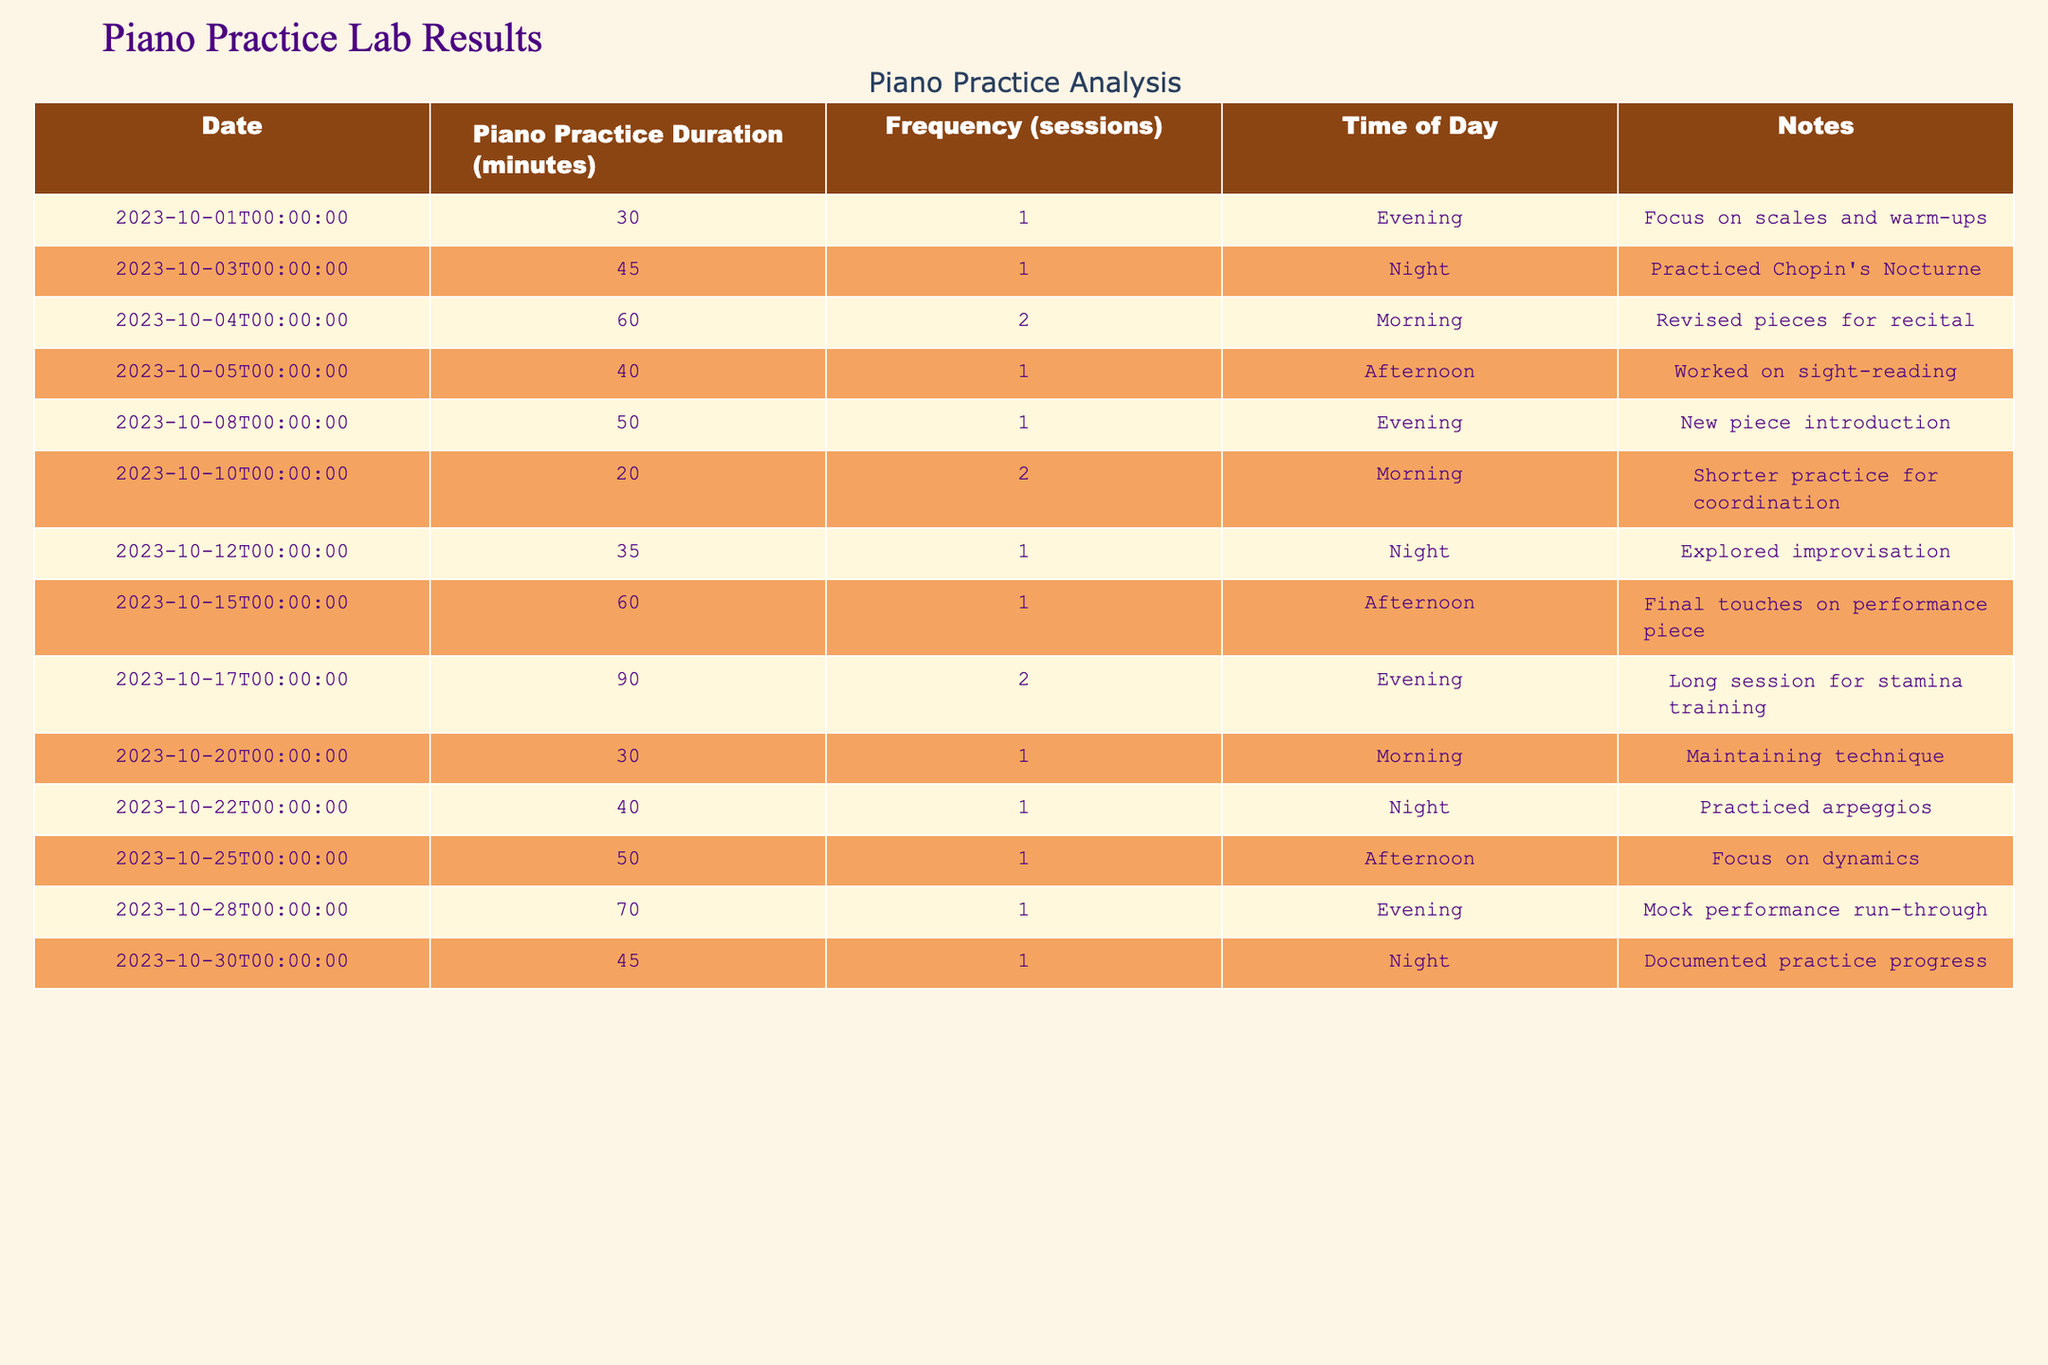What was the longest piano practice duration recorded in the month? The longest duration is found by scanning the "Piano Practice Duration (minutes)" column. The highest value is 90 minutes on 2023-10-17.
Answer: 90 minutes How many practice sessions were there in total over the month? To find the total number of sessions, sum the values in the "Frequency (sessions)" column. The total is 1 + 1 + 2 + 1 + 1 + 2 + 1 + 1 + 2 + 1 + 1 + 1 = 15.
Answer: 15 sessions On which dates was practice conducted only in the evening? To find the dates with practice only in the evening, look at each row. The dates are 2023-10-01, 2023-10-08, 2023-10-17, and 2023-10-28.
Answer: 2023-10-01, 2023-10-08, 2023-10-17, 2023-10-28 What was the average piano practice duration over the month? First, sum the practice durations: 30 + 45 + 60 + 40 + 50 + 20 + 35 + 60 + 90 + 30 + 40 + 50 + 70 + 45 = 730 minutes. Then divide by the number of entries (14): 730/14 = approximately 52.14 minutes.
Answer: 52.14 minutes Did the pianist practice more sessions during the evening than during the morning? Count the sessions for evening (1 + 1 + 2 + 1 = 5) and for morning (2 + 1 + 1 = 4). The comparison shows 5 (evening) > 4 (morning), so yes, more sessions were in the evening.
Answer: Yes On which day did the pianist have the second longest practice duration? First, identify the lengths: 90, 70, 60, 60, etc. The second longest is 70 minutes on 2023-10-28.
Answer: 2023-10-28 How many days did the pianist practice in the afternoon? Look at the "Time of Day" column and count the instances of "Afternoon," which appears on 2023-10-05, 2023-10-15, and 2023-10-25. That results in 3 days.
Answer: 3 days What percentage of sessions were held in the night compared to total sessions? Count the night sessions (1 + 1 + 1 + 1 = 4) and take the percentage: (4/15) * 100 = approximately 26.67%.
Answer: Approximately 26.67% 